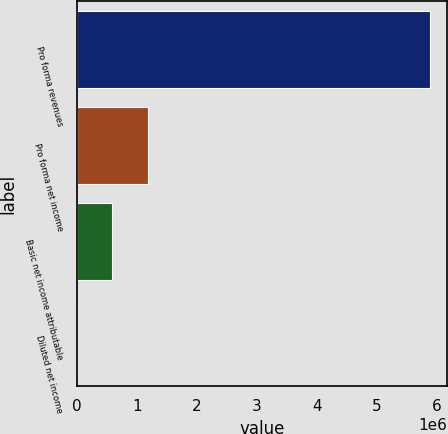Convert chart to OTSL. <chart><loc_0><loc_0><loc_500><loc_500><bar_chart><fcel>Pro forma revenues<fcel>Pro forma net income<fcel>Basic net income attributable<fcel>Diluted net income<nl><fcel>5.88669e+06<fcel>1.17734e+06<fcel>588670<fcel>1.27<nl></chart> 